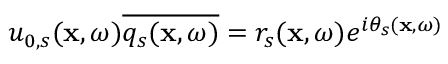Convert formula to latex. <formula><loc_0><loc_0><loc_500><loc_500>u _ { 0 , s } ( x , \omega ) \overline { { q _ { s } ( x , \omega ) } } = r _ { s } ( x , \omega ) e ^ { i \theta _ { s } ( x , \omega ) }</formula> 